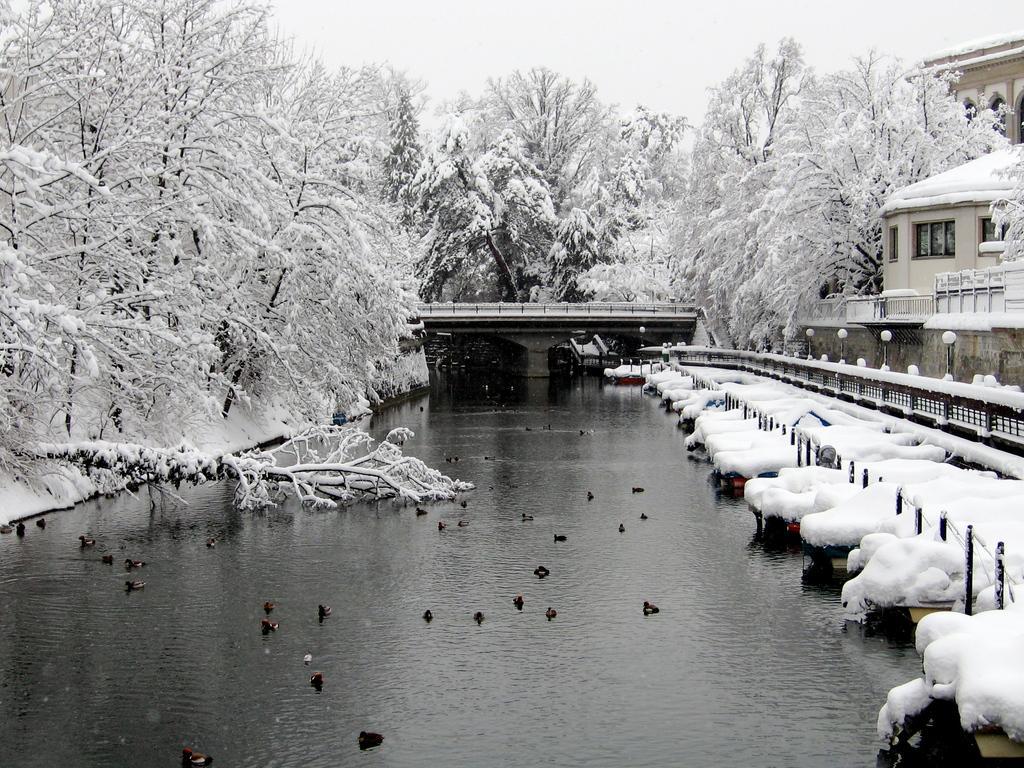In one or two sentences, can you explain what this image depicts? In the center of the image there are birds in the water. On the right side of the image there are boats. There are poles. There is a metal fence. There are buildings. In the center of the image there is a bridge. In the background of the image there are trees with snow on it and there is sky. 